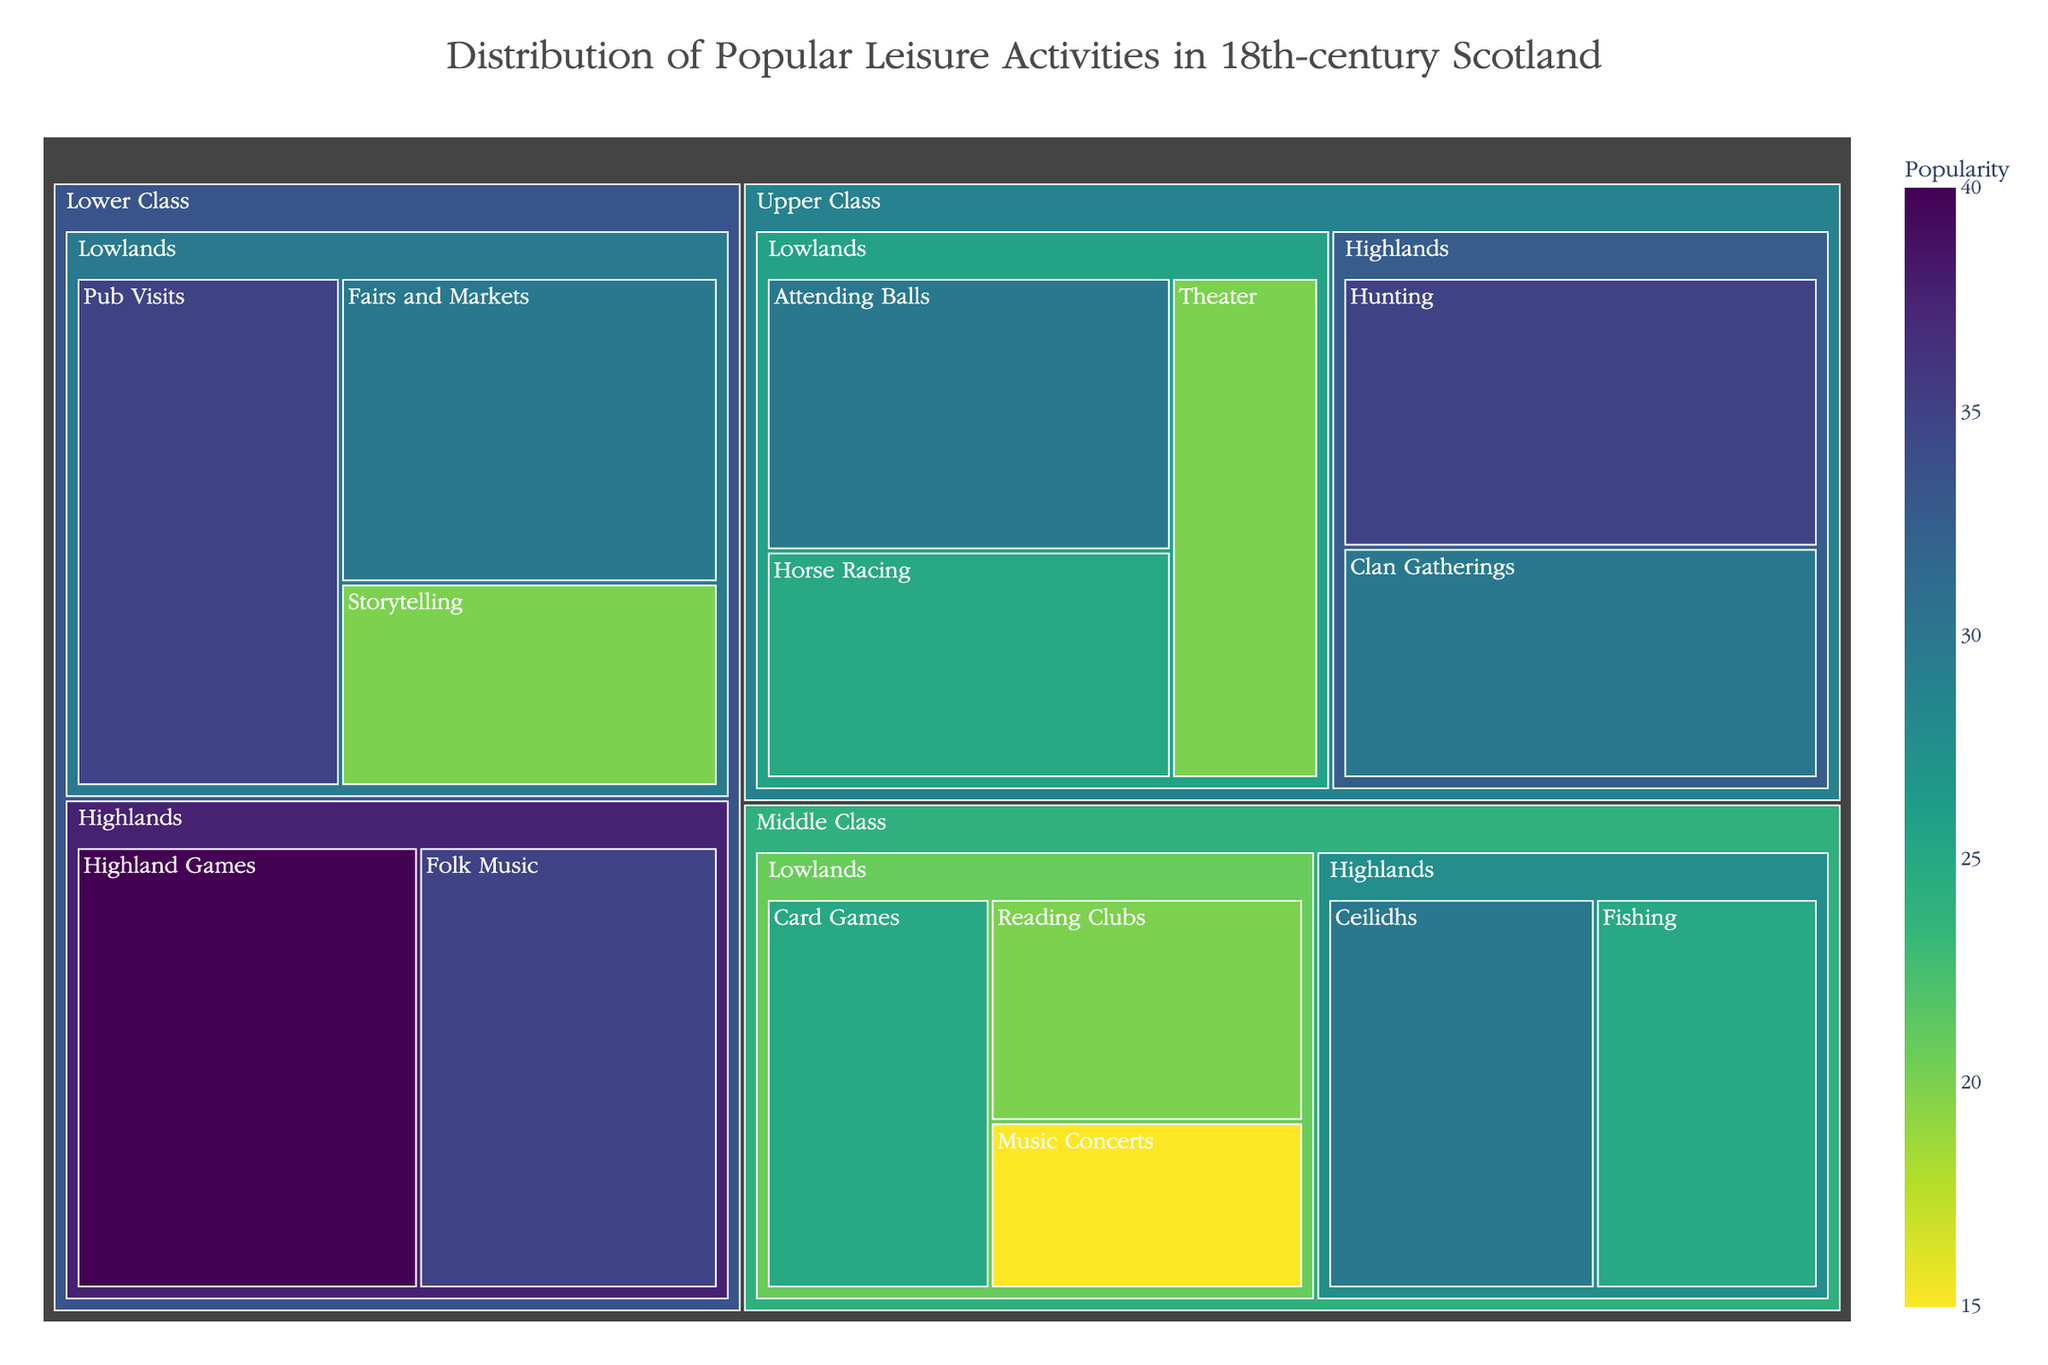Which category has the most popular single activity? In the Treemap, the activity with the highest value is 'Highland Games' (40) in the Lower Class in the Highlands. Therefore, the Lower Class category has the most popular single activity.
Answer: Lower Class What is the least popular activity in the Upper Class of the Lowlands? In the Treemap, among the activities listed under the Upper Class in the Lowlands, 'Theater' has the lowest value at 20.
Answer: Theater How does the popularity of 'Card Games' compare to 'Reading Clubs' in the Middle Class of the Lowlands? 'Card Games' has a value of 25 and 'Reading Clubs' has a value of 20 in the Middle Class of the Lowlands. 'Card Games' is more popular.
Answer: Card Games is more popular What is the total value of leisure activities for the Lower Class in the Lowlands? The leisure activities for the Lower Class in the Lowlands are 'Pub Visits' (35), 'Fairs and Markets' (30), and 'Storytelling' (20). Summing these values gives 35 + 30 + 20 = 85.
Answer: 85 Compare the popularity of 'Hunting' and 'Clan Gatherings' in the Upper Class of the Highlands. Which is more popular? 'Hunting' has a value of 35 and 'Clan Gatherings' has a value of 30 in the Upper Class of the Highlands. Therefore, 'Hunting' is more popular.
Answer: Hunting is more popular What is the average value of leisure activities in the Middle Class of the Highlands? The leisure activities for the Middle Class in the Highlands are 'Ceilidhs' (30) and 'Fishing' (25). The average is calculated as (30 + 25) / 2 = 27.5.
Answer: 27.5 Which social class in the Lowlands has the highest combined value for their leisure activities? Adding up the values for each social class in the Lowlands: Upper Class (30 + 25 + 20 = 75), Middle Class (25 + 20 + 15 = 60), Lower Class (35 + 30 + 20 = 85). The Lower Class has the highest combined value at 85.
Answer: Lower Class What is the most popular activity in the entire dataset? By scanning the Treemap, the activity with the highest value across all categories and regions is 'Highland Games' with a value of 40.
Answer: Highland Games 